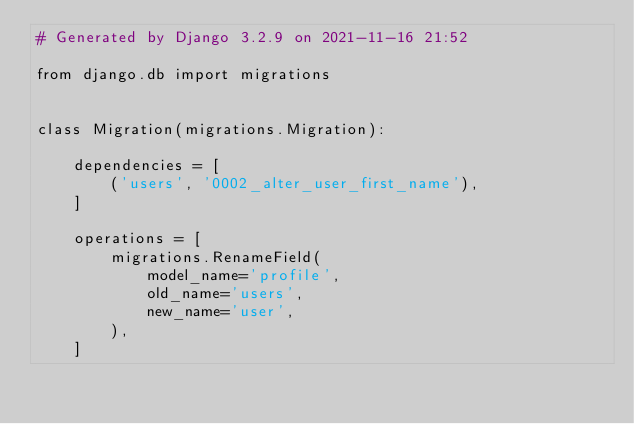Convert code to text. <code><loc_0><loc_0><loc_500><loc_500><_Python_># Generated by Django 3.2.9 on 2021-11-16 21:52

from django.db import migrations


class Migration(migrations.Migration):

    dependencies = [
        ('users', '0002_alter_user_first_name'),
    ]

    operations = [
        migrations.RenameField(
            model_name='profile',
            old_name='users',
            new_name='user',
        ),
    ]
</code> 